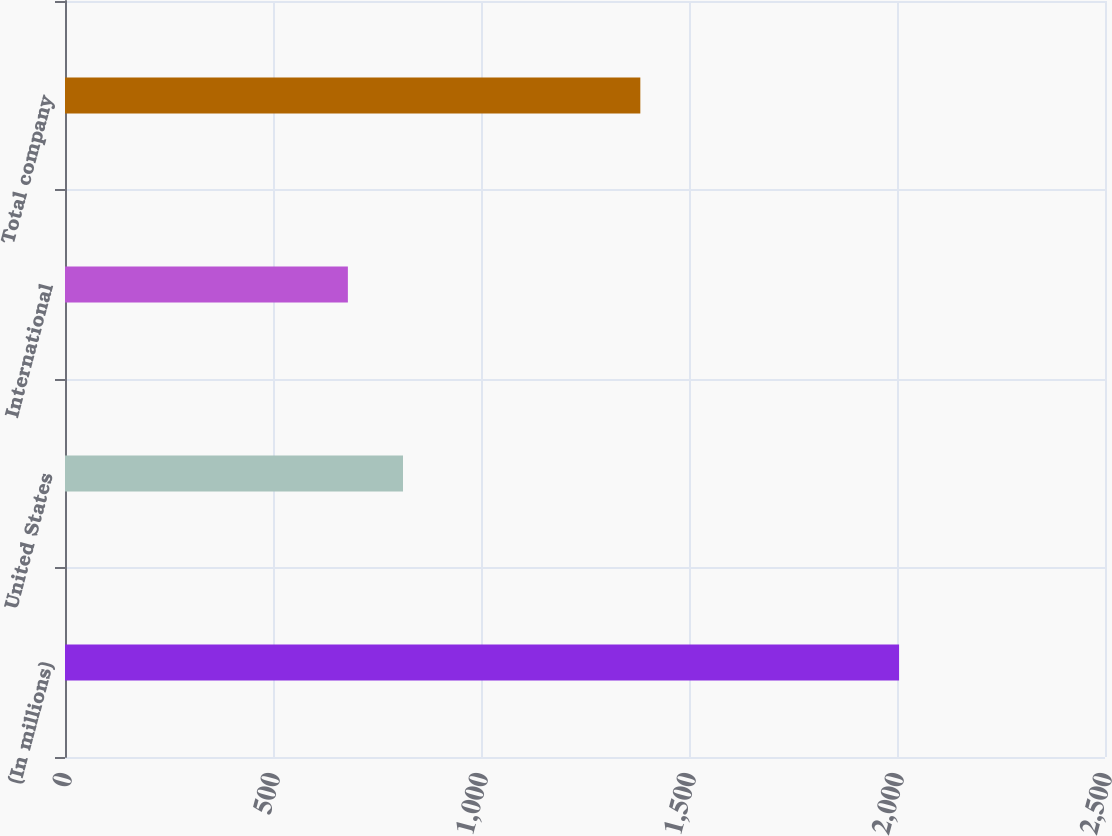Convert chart. <chart><loc_0><loc_0><loc_500><loc_500><bar_chart><fcel>(In millions)<fcel>United States<fcel>International<fcel>Total company<nl><fcel>2005<fcel>812.5<fcel>680<fcel>1383<nl></chart> 